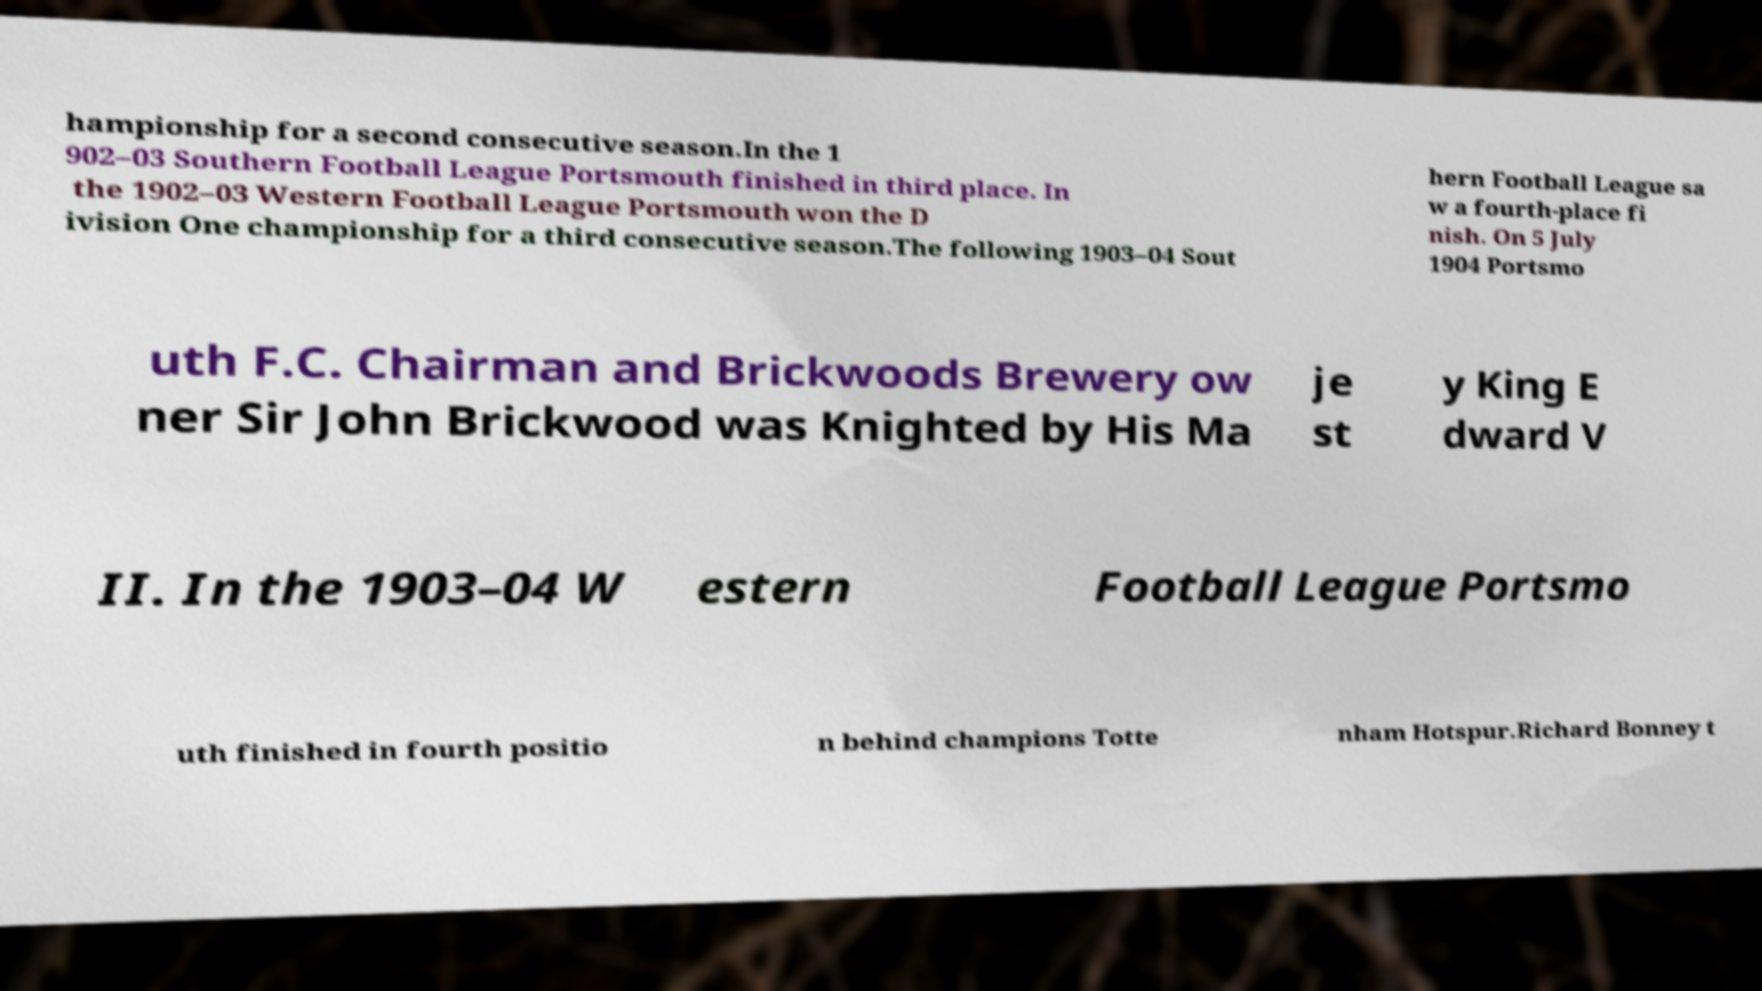For documentation purposes, I need the text within this image transcribed. Could you provide that? hampionship for a second consecutive season.In the 1 902–03 Southern Football League Portsmouth finished in third place. In the 1902–03 Western Football League Portsmouth won the D ivision One championship for a third consecutive season.The following 1903–04 Sout hern Football League sa w a fourth-place fi nish. On 5 July 1904 Portsmo uth F.C. Chairman and Brickwoods Brewery ow ner Sir John Brickwood was Knighted by His Ma je st y King E dward V II. In the 1903–04 W estern Football League Portsmo uth finished in fourth positio n behind champions Totte nham Hotspur.Richard Bonney t 